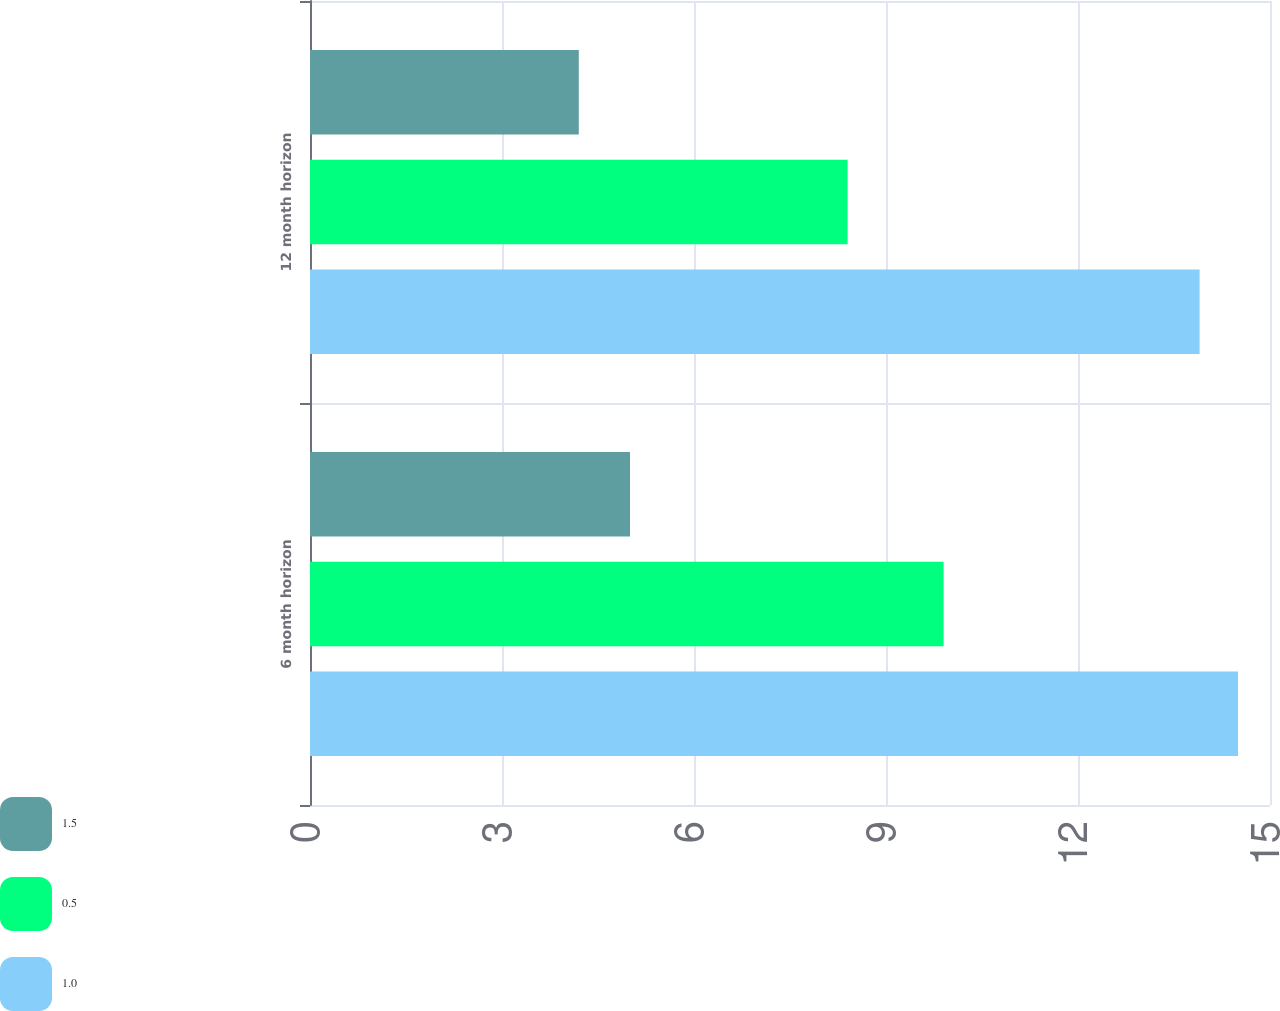Convert chart. <chart><loc_0><loc_0><loc_500><loc_500><stacked_bar_chart><ecel><fcel>6 month horizon<fcel>12 month horizon<nl><fcel>1.5<fcel>5<fcel>4.2<nl><fcel>0.5<fcel>9.9<fcel>8.4<nl><fcel>1<fcel>14.5<fcel>13.9<nl></chart> 